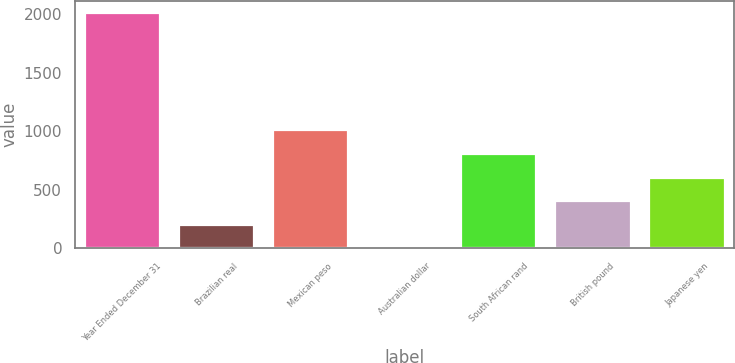Convert chart to OTSL. <chart><loc_0><loc_0><loc_500><loc_500><bar_chart><fcel>Year Ended December 31<fcel>Brazilian real<fcel>Mexican peso<fcel>Australian dollar<fcel>South African rand<fcel>British pound<fcel>Japanese yen<nl><fcel>2016<fcel>202.5<fcel>1008.5<fcel>1<fcel>807<fcel>404<fcel>605.5<nl></chart> 